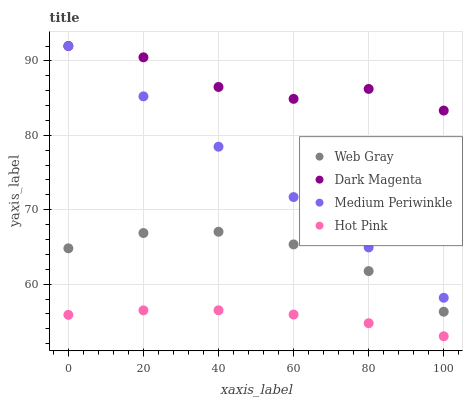Does Hot Pink have the minimum area under the curve?
Answer yes or no. Yes. Does Dark Magenta have the maximum area under the curve?
Answer yes or no. Yes. Does Medium Periwinkle have the minimum area under the curve?
Answer yes or no. No. Does Medium Periwinkle have the maximum area under the curve?
Answer yes or no. No. Is Medium Periwinkle the smoothest?
Answer yes or no. Yes. Is Dark Magenta the roughest?
Answer yes or no. Yes. Is Dark Magenta the smoothest?
Answer yes or no. No. Is Medium Periwinkle the roughest?
Answer yes or no. No. Does Hot Pink have the lowest value?
Answer yes or no. Yes. Does Medium Periwinkle have the lowest value?
Answer yes or no. No. Does Dark Magenta have the highest value?
Answer yes or no. Yes. Does Hot Pink have the highest value?
Answer yes or no. No. Is Hot Pink less than Web Gray?
Answer yes or no. Yes. Is Dark Magenta greater than Hot Pink?
Answer yes or no. Yes. Does Dark Magenta intersect Medium Periwinkle?
Answer yes or no. Yes. Is Dark Magenta less than Medium Periwinkle?
Answer yes or no. No. Is Dark Magenta greater than Medium Periwinkle?
Answer yes or no. No. Does Hot Pink intersect Web Gray?
Answer yes or no. No. 